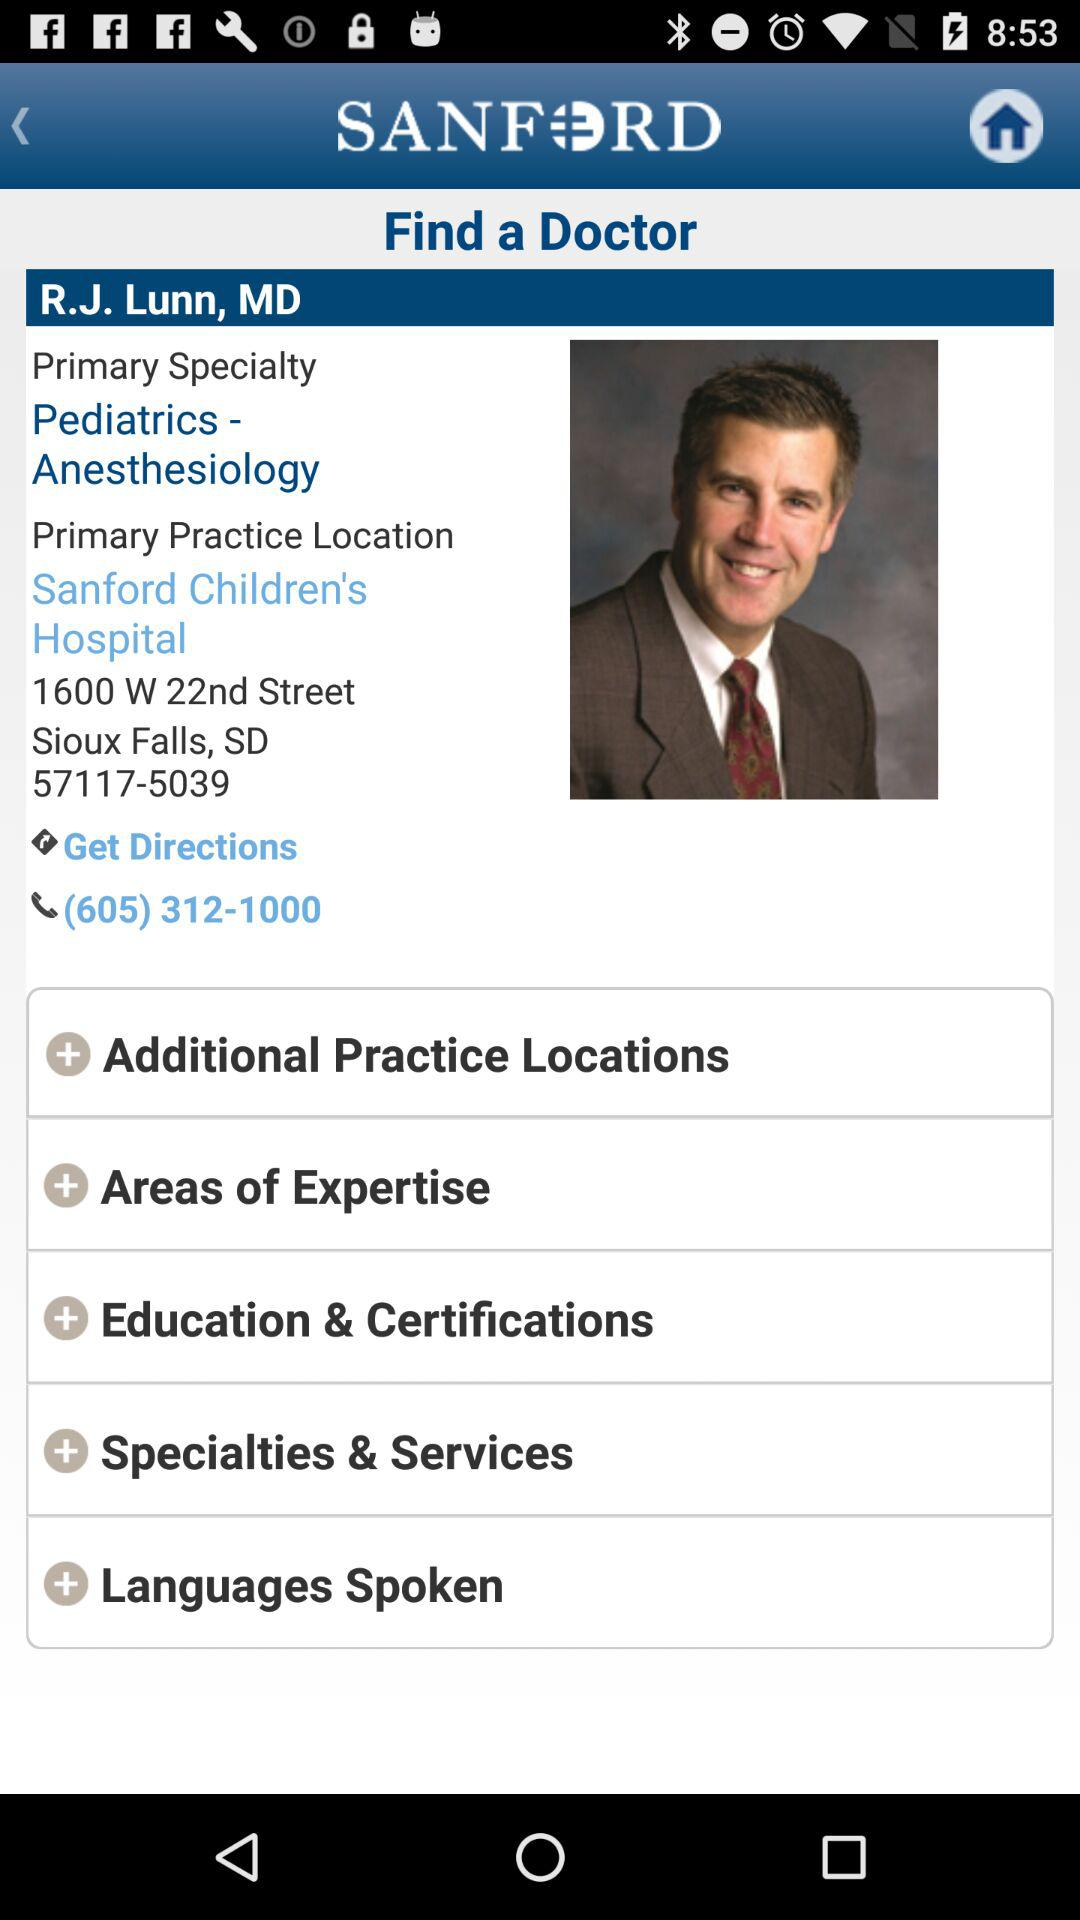What is the address of the hospital? The address of the hospital is 1600 W 22nd Street, Sioux Falls, SD 57117-5039. 